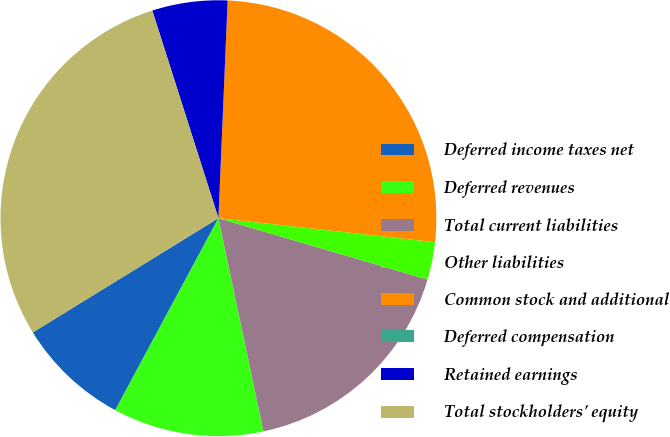Convert chart. <chart><loc_0><loc_0><loc_500><loc_500><pie_chart><fcel>Deferred income taxes net<fcel>Deferred revenues<fcel>Total current liabilities<fcel>Other liabilities<fcel>Common stock and additional<fcel>Deferred compensation<fcel>Retained earnings<fcel>Total stockholders' equity<nl><fcel>8.37%<fcel>11.16%<fcel>17.14%<fcel>2.79%<fcel>26.08%<fcel>0.0%<fcel>5.58%<fcel>28.87%<nl></chart> 